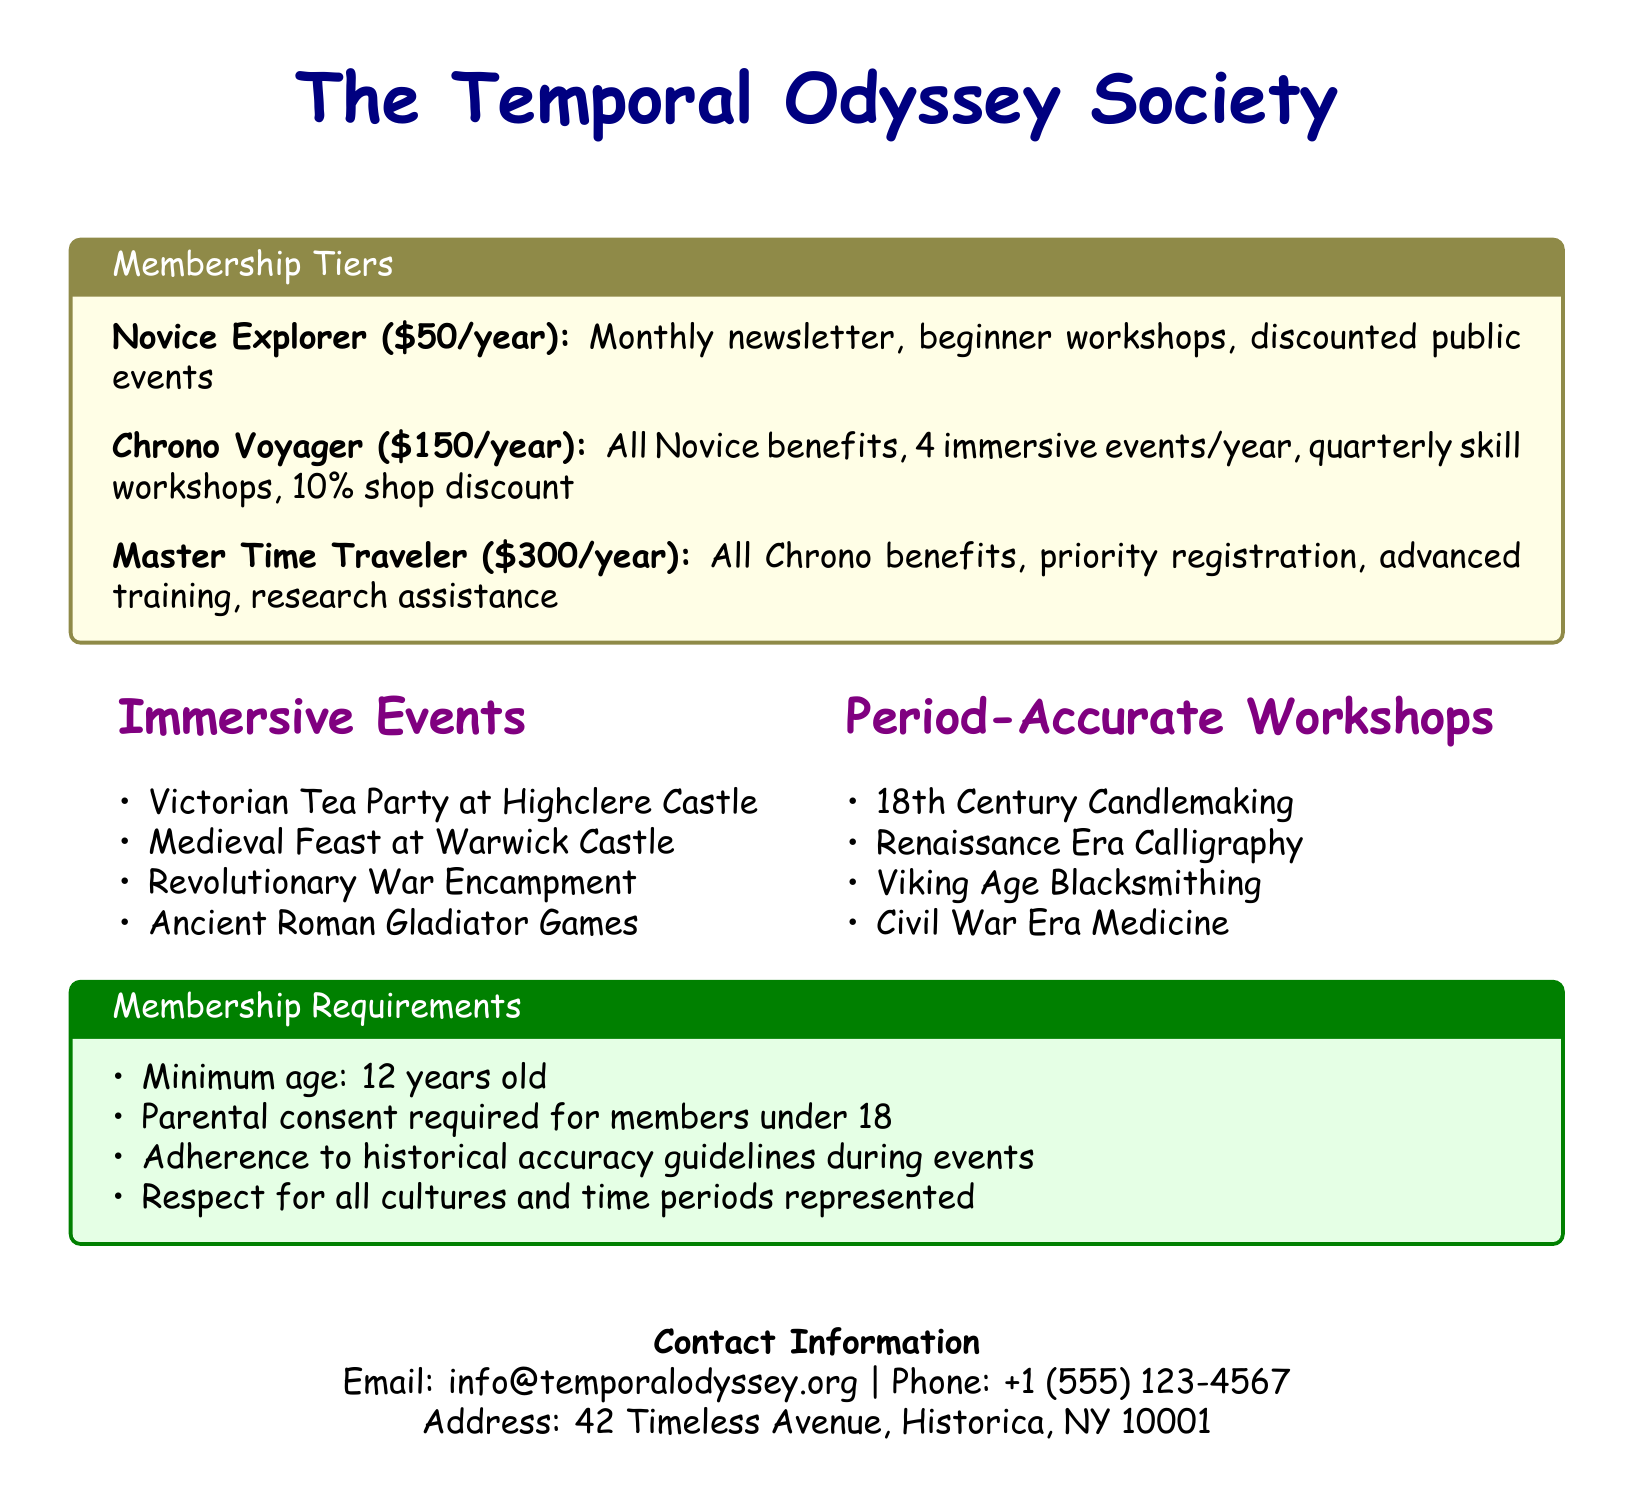What is the name of the society? The name is found in the title of the document, which states "The Temporal Odyssey Society."
Answer: The Temporal Odyssey Society How much is the fee for a Novice Explorer membership? The membership tiers section lists the fee for a Novice Explorer as $50/year.
Answer: $50/year What are the benefits of the Chrono Voyager membership? Chrono Voyager members receive all Novice benefits, 4 immersive events/year, quarterly skill workshops, and a 10% shop discount.
Answer: All Novice benefits, 4 immersive events/year, quarterly skill workshops, 10% shop discount How many immersive events does a Master Time Traveler member enjoy? The description of Master Time Traveler mentions all Chrono benefits but does not specify a number of events; thus, it can be inferred that they can enjoy immersive events, similar to the Chrono Voyager tier which includes 4 events per year.
Answer: 4 immersive events What is a requirement for members under 18 years old? The membership requirements state that parental consent is required for members under 18.
Answer: Parental consent Name one immersive event offered by the society. The list of immersive events provides examples such as "Victorian Tea Party at Highclere Castle," which is one of the events listed.
Answer: Victorian Tea Party at Highclere Castle Can a 10-year-old join the society? The minimum age requirement for membership is stated within the document, indicating that members must be at least 12 years old.
Answer: No What workshop focuses on blacksmithing skills? The section on period-accurate workshops includes "Viking Age Blacksmithing," which focuses explicitly on blacksmithing skills.
Answer: Viking Age Blacksmithing 